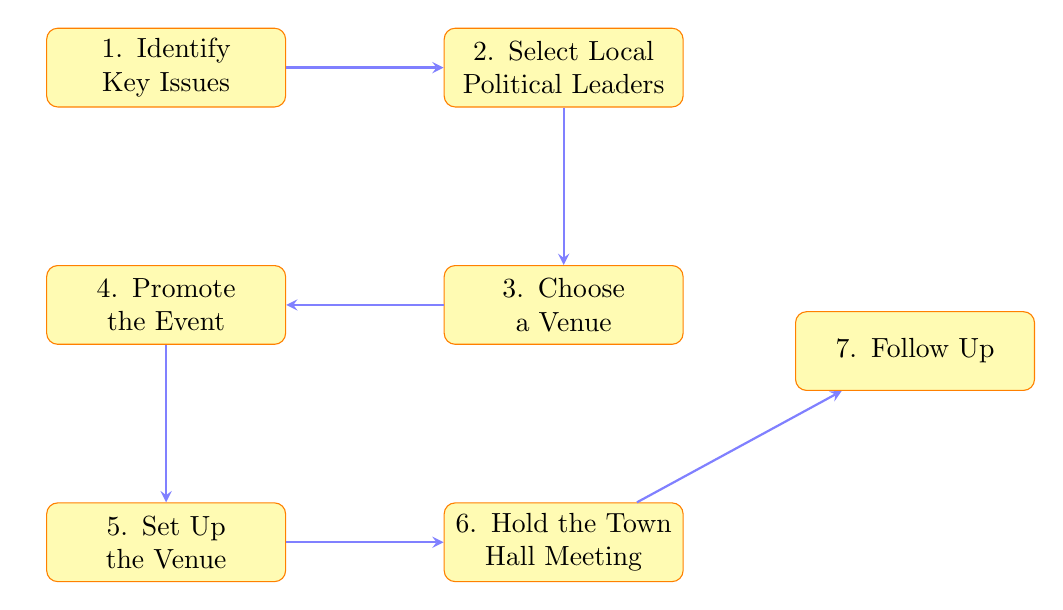What is the first step in the town hall meeting process? The diagram presents the flow of steps, with the first node clearly labeled as "1. Identify Key Issues." This indicates that identifying key issues is the initial task to begin the process.
Answer: Identify Key Issues How many steps are outlined in the diagram? By counting the nodes in the diagram, there are a total of seven steps indicated from "Identify Key Issues" to "Follow Up." Each step is represented as a separate node in the flow.
Answer: 7 Which step comes after "Choose a Venue"? Following the diagram's flow, we see that "Choose a Venue" is step three, and the next step indicated by the arrow is "Promote the Event," which is step four.
Answer: Promote the Event List the two steps adjacent to "Hold the Town Hall Meeting." The step before "Hold the Town Hall Meeting" is "Set Up the Venue," and the step after is "Follow Up." These two steps are directly connected above and below "Hold the Town Hall Meeting."
Answer: Set Up the Venue and Follow Up What step involves arranging seating and equipment? According to the diagram, "Set Up the Venue" includes the task of arranging seating, audio-visual equipment, and materials for the meeting, as shown in step five.
Answer: Set Up the Venue If you want to increase attendance, which step focuses on that? The diagram shows that "Promote the Event" directly addresses increasing awareness and attendance through social media and local news channels. This is step four in the sequence.
Answer: Promote the Event What is the last step according to the diagram? The final node in the flow chart is "Follow Up," which signifies the completion of the process with summarizing the event outcomes and planning subsequent actions.
Answer: Follow Up Which nodes are directly connected to the "Select Local Political Leaders"? The node "Select Local Political Leaders" is connected to "Identify Key Issues" as its predecessor and "Choose a Venue" as its successor, making it a central point in the process.
Answer: Identify Key Issues and Choose a Venue 